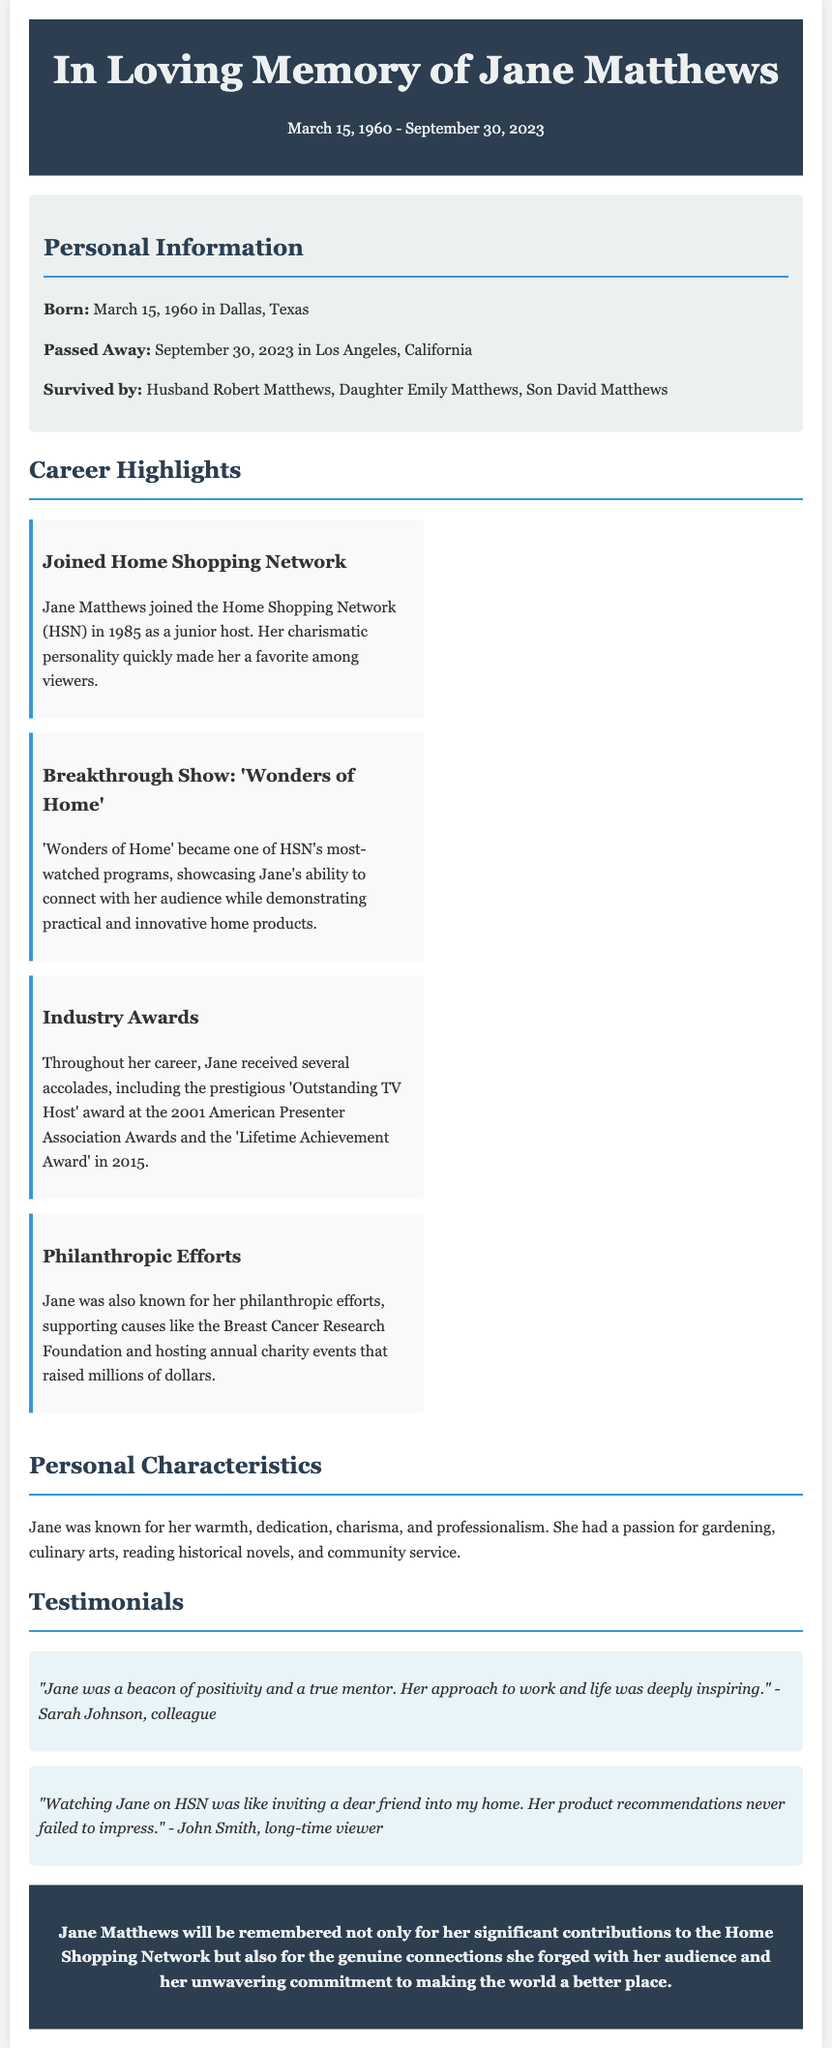what was Jane Matthews' role at HSN? Jane Matthews joined the Home Shopping Network (HSN) as a junior host, highlighting her entry-level position.
Answer: junior host when did Jane Matthews pass away? The document clearly states the date of Jane Matthews' passing.
Answer: September 30, 2023 what award did Jane receive in 2001? The document specifies the award she received in that year, emphasizing recognition in her field.
Answer: Outstanding TV Host who are the surviving family members of Jane Matthews? The document lists her immediate family who survived her, providing insight into her personal life.
Answer: Husband Robert Matthews, Daughter Emily Matthews, Son David Matthews what was the name of Jane's breakthrough show? The document mentions the title of the show that marked a significant point in her career.
Answer: Wonders of Home how many years did Jane Matthews host at HSN before receiving the Lifetime Achievement Award? Reasoning through her start year (1985) and the award year (2015), we calculate the span of her career.
Answer: 30 years what philanthropic cause was Jane known to support? The document references a specific foundation that she contributed to.
Answer: Breast Cancer Research Foundation what characteristics defined Jane Matthews personally? The document summarizes key traits that reflect her personality and work ethic.
Answer: warmth, dedication, charisma, and professionalism how is Jane Matthews remembered according to the obituary? The conclusion of the document summarizes her legacy and impact based on the content presented.
Answer: significant contributions to the Home Shopping Network 